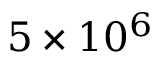<formula> <loc_0><loc_0><loc_500><loc_500>{ 5 \times 1 0 ^ { 6 } }</formula> 